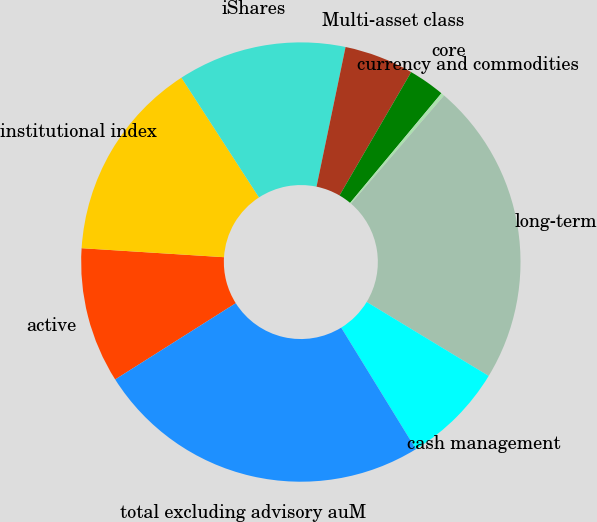Convert chart to OTSL. <chart><loc_0><loc_0><loc_500><loc_500><pie_chart><fcel>active<fcel>institutional index<fcel>iShares<fcel>Multi-asset class<fcel>core<fcel>currency and commodities<fcel>long-term<fcel>cash management<fcel>total excluding advisory auM<nl><fcel>9.98%<fcel>14.85%<fcel>12.41%<fcel>5.11%<fcel>2.68%<fcel>0.25%<fcel>22.37%<fcel>7.55%<fcel>24.8%<nl></chart> 